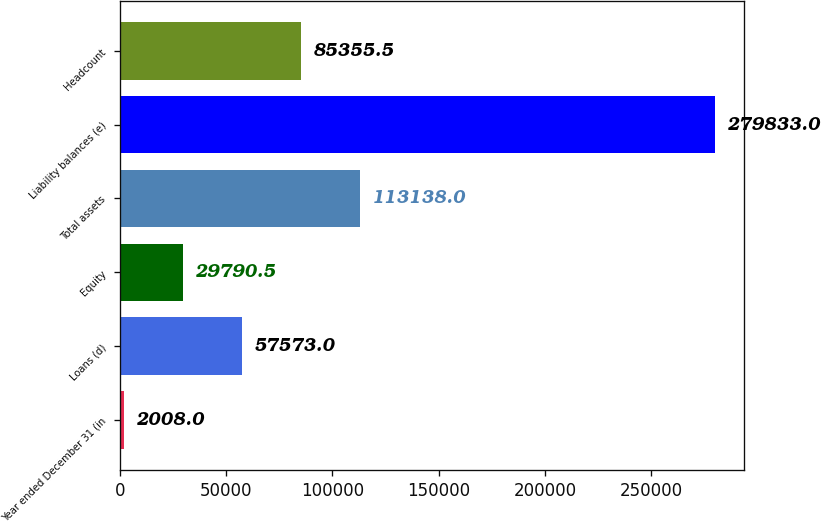<chart> <loc_0><loc_0><loc_500><loc_500><bar_chart><fcel>Year ended December 31 (in<fcel>Loans (d)<fcel>Equity<fcel>Total assets<fcel>Liability balances (e)<fcel>Headcount<nl><fcel>2008<fcel>57573<fcel>29790.5<fcel>113138<fcel>279833<fcel>85355.5<nl></chart> 